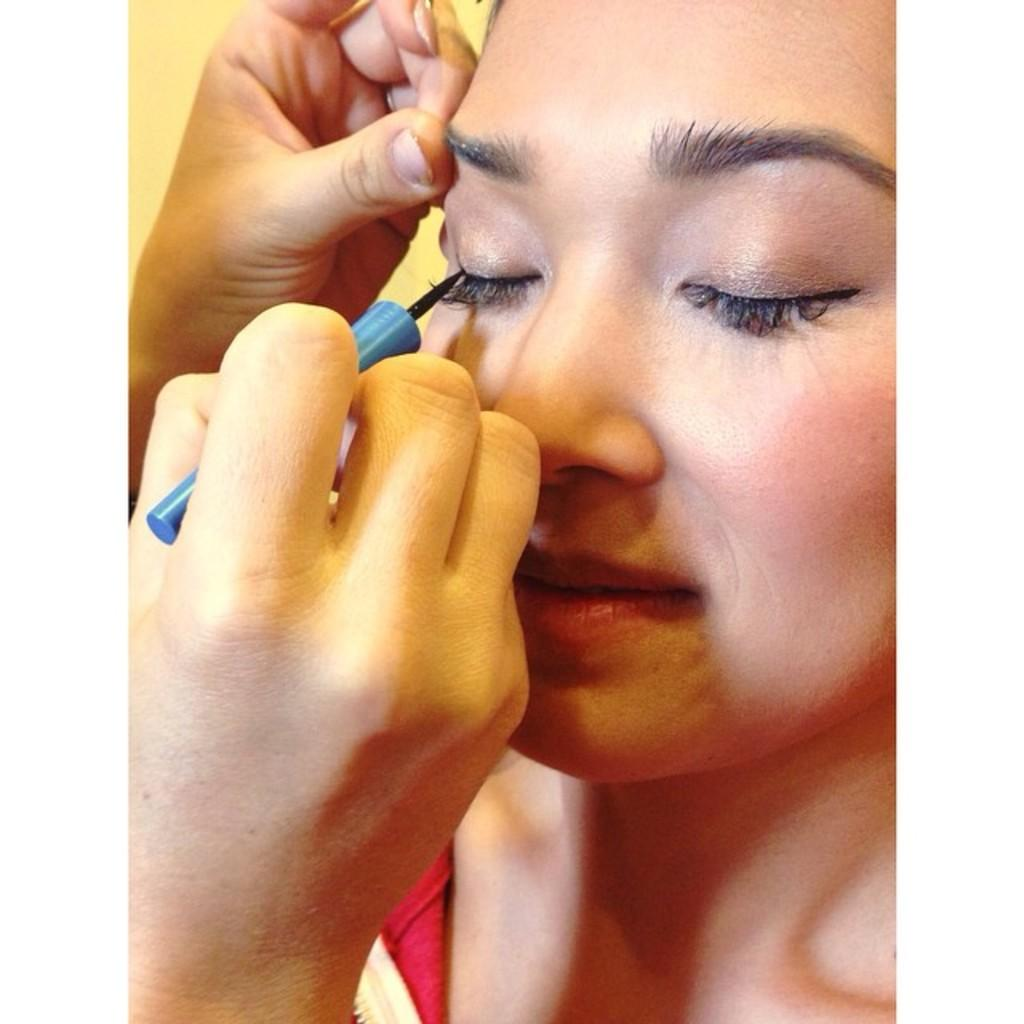Who is the main subject in the image? There is a woman in the image. What is the woman doing in the image? The woman is not doing anything specific in the image. What is the other person in the image doing? The other person is doing makeup to the woman. What type of instrument is the woman playing in the image? There is no instrument present in the image, and the woman is not playing any instrument. 